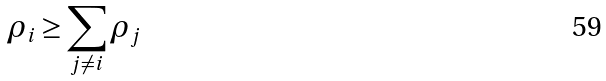<formula> <loc_0><loc_0><loc_500><loc_500>\rho _ { i } \geq \sum _ { j \ne i } \rho _ { j }</formula> 